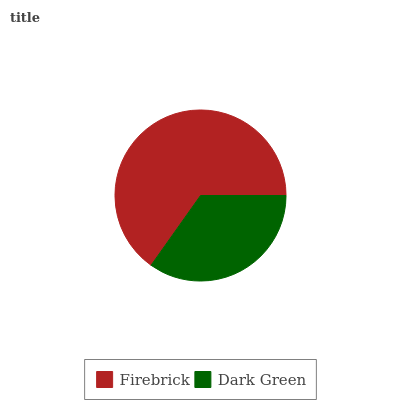Is Dark Green the minimum?
Answer yes or no. Yes. Is Firebrick the maximum?
Answer yes or no. Yes. Is Dark Green the maximum?
Answer yes or no. No. Is Firebrick greater than Dark Green?
Answer yes or no. Yes. Is Dark Green less than Firebrick?
Answer yes or no. Yes. Is Dark Green greater than Firebrick?
Answer yes or no. No. Is Firebrick less than Dark Green?
Answer yes or no. No. Is Firebrick the high median?
Answer yes or no. Yes. Is Dark Green the low median?
Answer yes or no. Yes. Is Dark Green the high median?
Answer yes or no. No. Is Firebrick the low median?
Answer yes or no. No. 